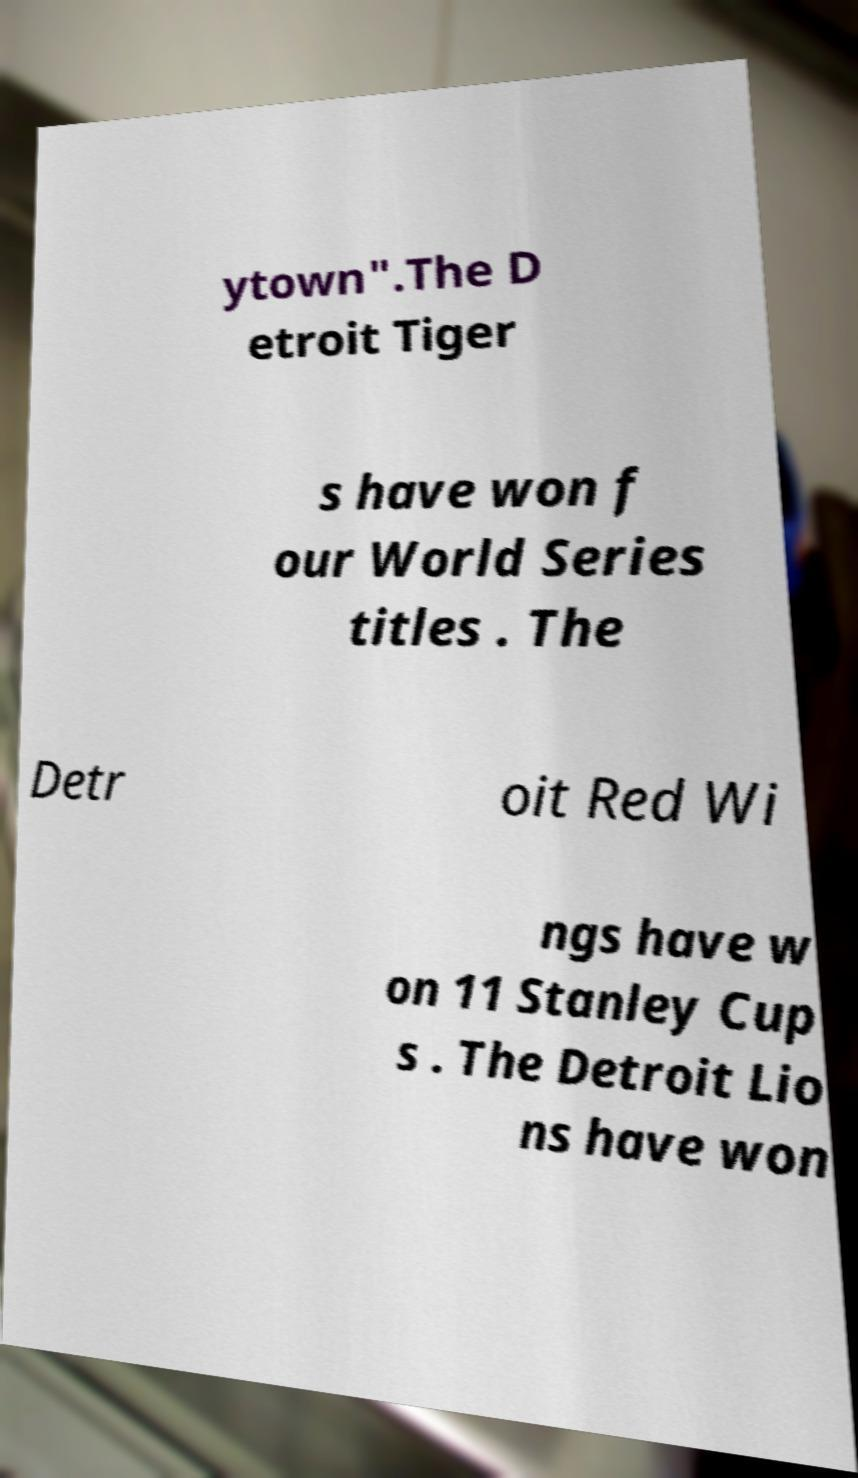What messages or text are displayed in this image? I need them in a readable, typed format. ytown".The D etroit Tiger s have won f our World Series titles . The Detr oit Red Wi ngs have w on 11 Stanley Cup s . The Detroit Lio ns have won 